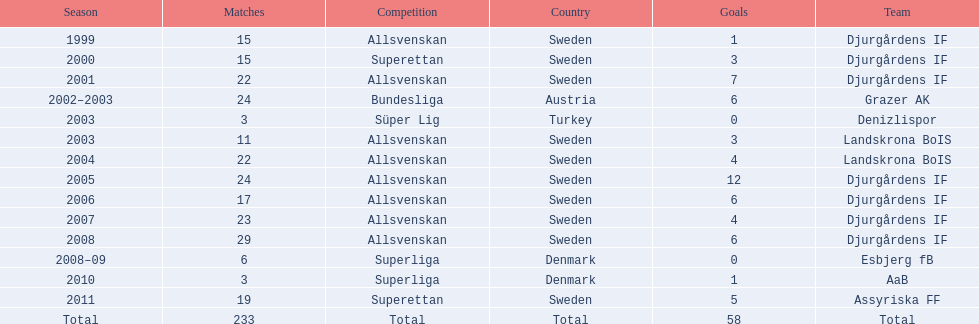During which season do players score the maximum goals? 2005. 